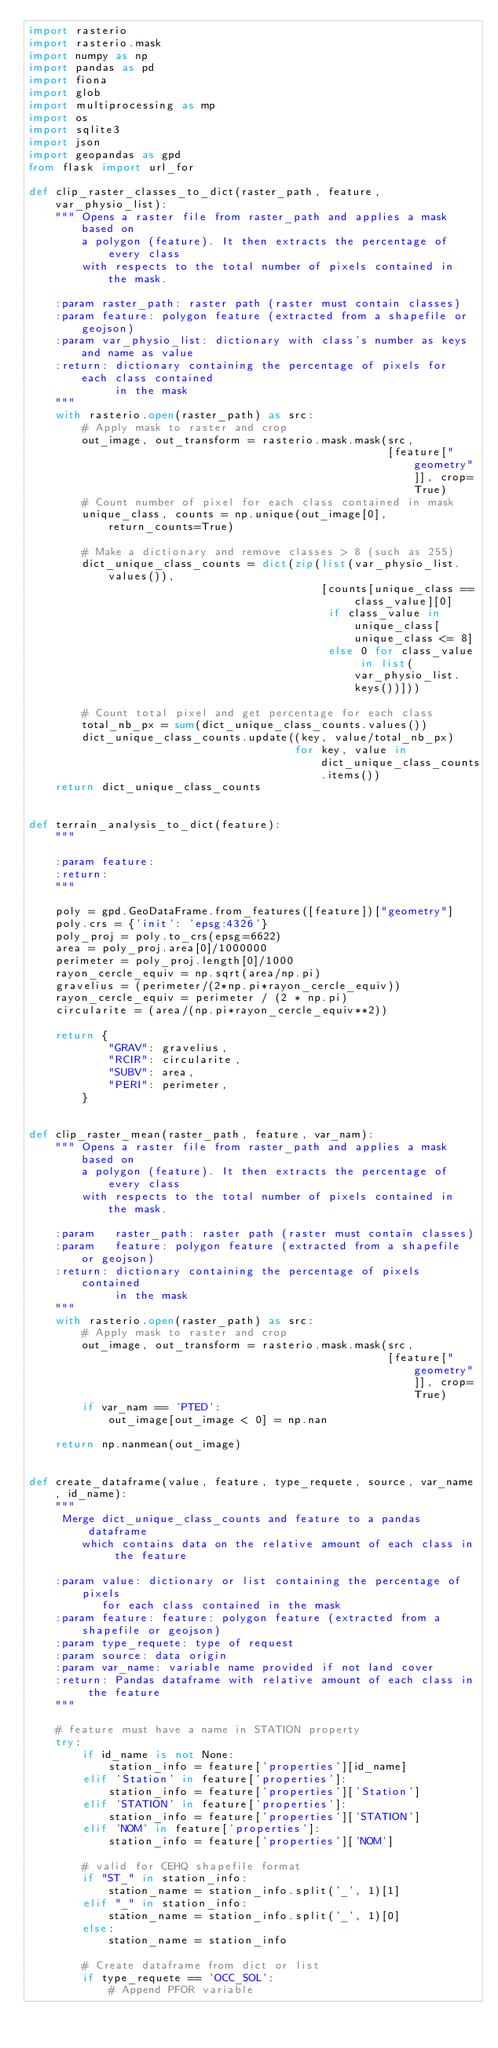Convert code to text. <code><loc_0><loc_0><loc_500><loc_500><_Python_>import rasterio
import rasterio.mask
import numpy as np
import pandas as pd
import fiona
import glob
import multiprocessing as mp
import os
import sqlite3
import json
import geopandas as gpd
from flask import url_for

def clip_raster_classes_to_dict(raster_path, feature, var_physio_list):
    """ Opens a raster file from raster_path and applies a mask based on
        a polygon (feature). It then extracts the percentage of every class
        with respects to the total number of pixels contained in the mask.

    :param raster_path: raster path (raster must contain classes)
    :param feature: polygon feature (extracted from a shapefile or geojson)
    :param var_physio_list: dictionary with class's number as keys and name as value
    :return: dictionary containing the percentage of pixels for each class contained
             in the mask
    """
    with rasterio.open(raster_path) as src:
        # Apply mask to raster and crop
        out_image, out_transform = rasterio.mask.mask(src,
                                                      [feature["geometry"]], crop=True)
        # Count number of pixel for each class contained in mask
        unique_class, counts = np.unique(out_image[0], return_counts=True)

        # Make a dictionary and remove classes > 8 (such as 255)
        dict_unique_class_counts = dict(zip(list(var_physio_list.values()),
                                            [counts[unique_class == class_value][0]
                                             if class_value in unique_class[unique_class <= 8]
                                             else 0 for class_value in list(var_physio_list.keys())]))

        # Count total pixel and get percentage for each class
        total_nb_px = sum(dict_unique_class_counts.values())
        dict_unique_class_counts.update((key, value/total_nb_px)
                                        for key, value in dict_unique_class_counts.items())
    return dict_unique_class_counts


def terrain_analysis_to_dict(feature):
    """

    :param feature:
    :return:
    """

    poly = gpd.GeoDataFrame.from_features([feature])["geometry"]
    poly.crs = {'init': 'epsg:4326'}
    poly_proj = poly.to_crs(epsg=6622)
    area = poly_proj.area[0]/1000000
    perimeter = poly_proj.length[0]/1000
    rayon_cercle_equiv = np.sqrt(area/np.pi)
    gravelius = (perimeter/(2*np.pi*rayon_cercle_equiv))
    rayon_cercle_equiv = perimeter / (2 * np.pi)
    circularite = (area/(np.pi*rayon_cercle_equiv**2))

    return {
            "GRAV": gravelius,
            "RCIR": circularite,
            "SUBV": area,
            "PERI": perimeter,
        }


def clip_raster_mean(raster_path, feature, var_nam):
    """ Opens a raster file from raster_path and applies a mask based on
        a polygon (feature). It then extracts the percentage of every class
        with respects to the total number of pixels contained in the mask.

    :param   raster_path: raster path (raster must contain classes)
    :param   feature: polygon feature (extracted from a shapefile or geojson)
    :return: dictionary containing the percentage of pixels contained
             in the mask
    """
    with rasterio.open(raster_path) as src:
        # Apply mask to raster and crop
        out_image, out_transform = rasterio.mask.mask(src,
                                                      [feature["geometry"]], crop=True)
        if var_nam == 'PTED':
            out_image[out_image < 0] = np.nan

    return np.nanmean(out_image)


def create_dataframe(value, feature, type_requete, source, var_name, id_name):
    """
     Merge dict_unique_class_counts and feature to a pandas dataframe
        which contains data on the relative amount of each class in the feature

    :param value: dictionary or list containing the percentage of pixels
           for each class contained in the mask
    :param feature: feature: polygon feature (extracted from a shapefile or geojson)
    :param type_requete: type of request
    :param source: data origin
    :param var_name: variable name provided if not land cover
    :return: Pandas dataframe with relative amount of each class in the feature
    """

    # feature must have a name in STATION property
    try:
        if id_name is not None:
            station_info = feature['properties'][id_name]
        elif 'Station' in feature['properties']:
            station_info = feature['properties']['Station']
        elif 'STATION' in feature['properties']:
            station_info = feature['properties']['STATION']
        elif 'NOM' in feature['properties']:
            station_info = feature['properties']['NOM']

        # valid for CEHQ shapefile format
        if "ST_" in station_info:
            station_name = station_info.split('_', 1)[1]
        elif "_" in station_info:
            station_name = station_info.split('_', 1)[0]
        else:
            station_name = station_info

        # Create dataframe from dict or list
        if type_requete == 'OCC_SOL':
            # Append PFOR variable</code> 